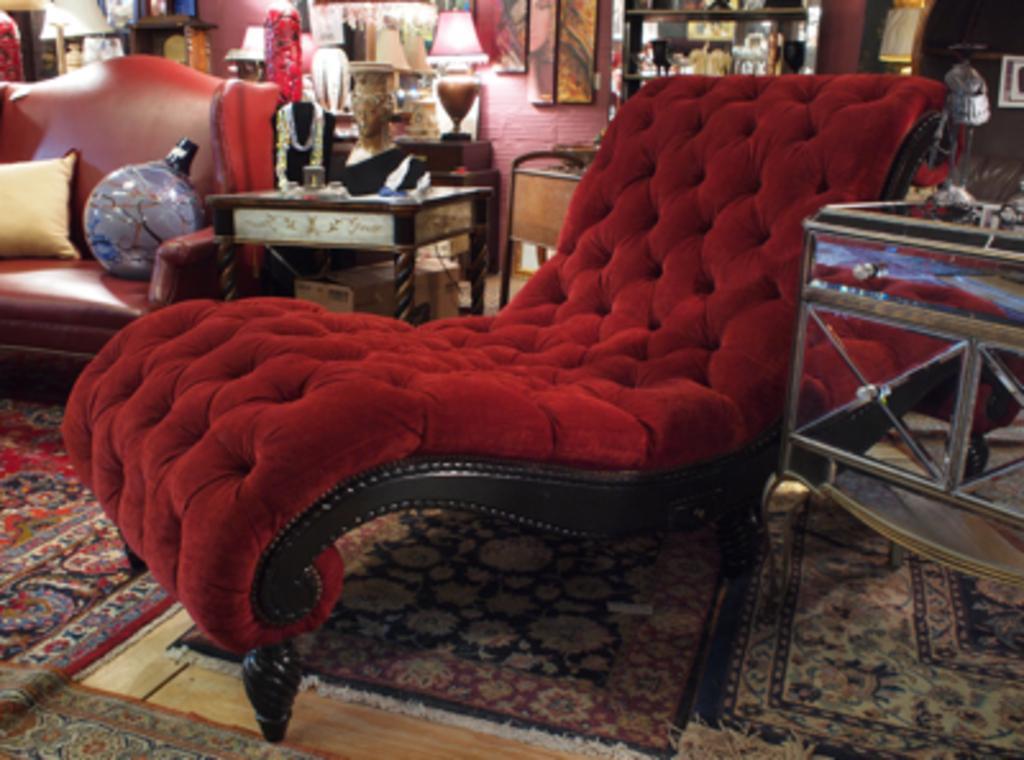Can you describe this image briefly? In the center we can see chair. On the back we can see couch,on couch pillow,globe,wall,tables on table some more objects,frame and few objects around them. 